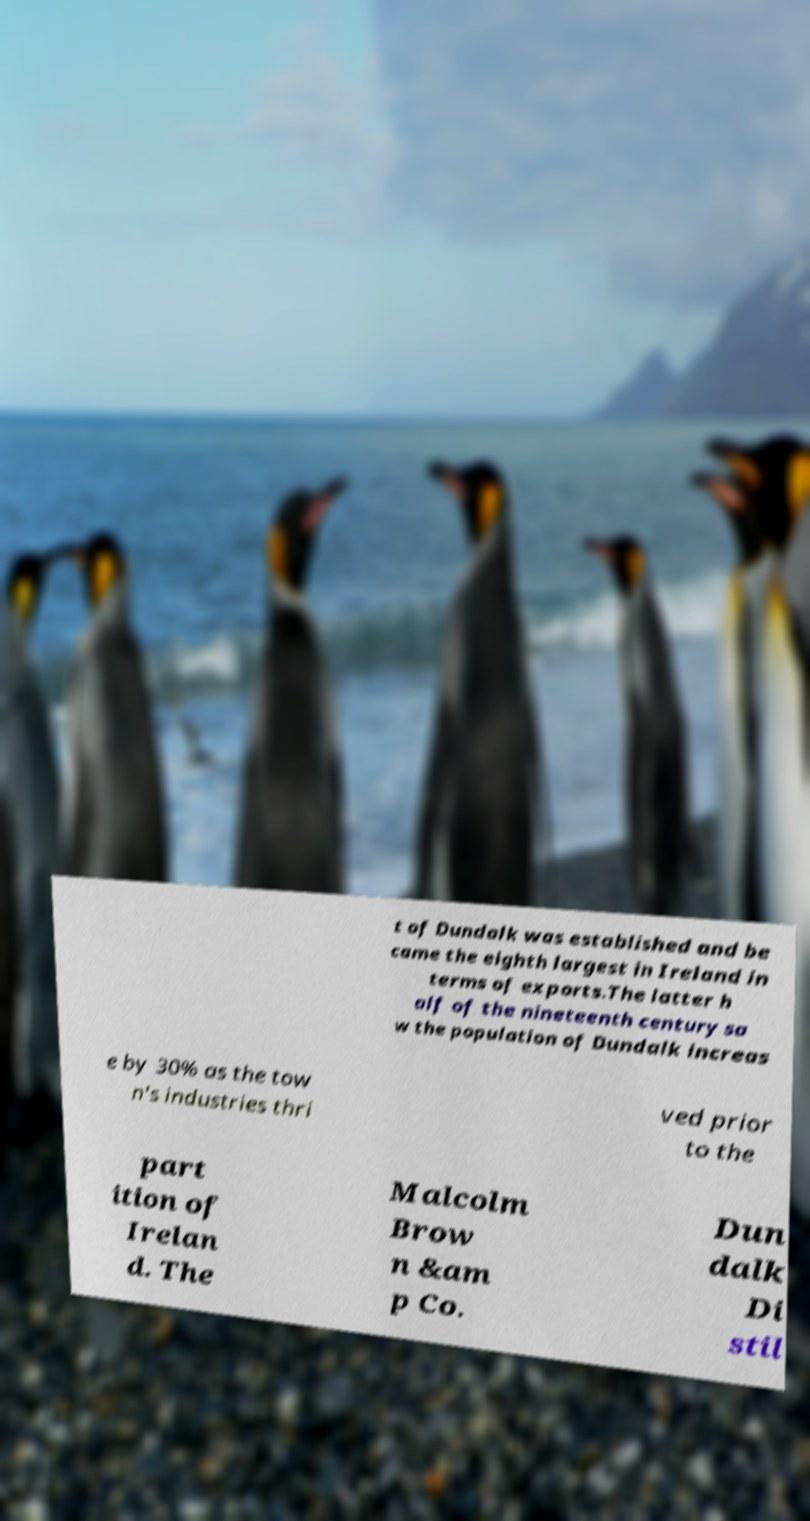Can you accurately transcribe the text from the provided image for me? t of Dundalk was established and be came the eighth largest in Ireland in terms of exports.The latter h alf of the nineteenth century sa w the population of Dundalk increas e by 30% as the tow n's industries thri ved prior to the part ition of Irelan d. The Malcolm Brow n &am p Co. Dun dalk Di stil 